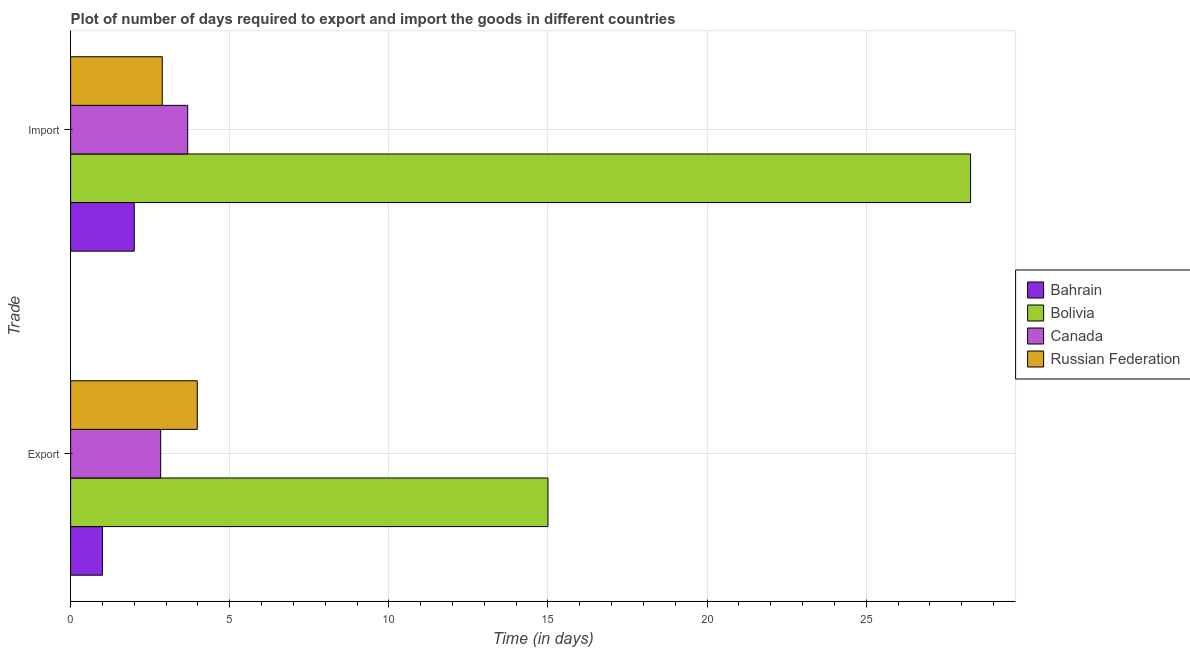How many groups of bars are there?
Provide a succinct answer. 2. Are the number of bars on each tick of the Y-axis equal?
Your response must be concise. Yes. What is the label of the 1st group of bars from the top?
Give a very brief answer. Import. Across all countries, what is the minimum time required to import?
Your response must be concise. 2. In which country was the time required to export maximum?
Keep it short and to the point. Bolivia. In which country was the time required to export minimum?
Your answer should be very brief. Bahrain. What is the total time required to import in the graph?
Give a very brief answer. 36.84. What is the difference between the time required to export in Bahrain and that in Canada?
Provide a succinct answer. -1.83. What is the difference between the time required to export in Bolivia and the time required to import in Russian Federation?
Give a very brief answer. 12.12. What is the average time required to import per country?
Your answer should be compact. 9.21. In how many countries, is the time required to import greater than 18 days?
Provide a succinct answer. 1. What is the ratio of the time required to import in Russian Federation to that in Bahrain?
Your response must be concise. 1.44. Is the time required to import in Bahrain less than that in Canada?
Ensure brevity in your answer.  Yes. In how many countries, is the time required to export greater than the average time required to export taken over all countries?
Make the answer very short. 1. What does the 2nd bar from the top in Import represents?
Provide a succinct answer. Canada. How many countries are there in the graph?
Offer a very short reply. 4. Does the graph contain grids?
Give a very brief answer. Yes. Where does the legend appear in the graph?
Provide a short and direct response. Center right. What is the title of the graph?
Your answer should be compact. Plot of number of days required to export and import the goods in different countries. Does "Lower middle income" appear as one of the legend labels in the graph?
Your answer should be very brief. No. What is the label or title of the X-axis?
Offer a very short reply. Time (in days). What is the label or title of the Y-axis?
Keep it short and to the point. Trade. What is the Time (in days) in Bahrain in Export?
Your answer should be very brief. 1. What is the Time (in days) of Bolivia in Export?
Provide a succinct answer. 15. What is the Time (in days) of Canada in Export?
Offer a very short reply. 2.83. What is the Time (in days) of Russian Federation in Export?
Your answer should be compact. 3.98. What is the Time (in days) of Bahrain in Import?
Provide a succinct answer. 2. What is the Time (in days) in Bolivia in Import?
Provide a succinct answer. 28.28. What is the Time (in days) of Canada in Import?
Your answer should be very brief. 3.68. What is the Time (in days) of Russian Federation in Import?
Make the answer very short. 2.88. Across all Trade, what is the maximum Time (in days) in Bahrain?
Offer a very short reply. 2. Across all Trade, what is the maximum Time (in days) of Bolivia?
Give a very brief answer. 28.28. Across all Trade, what is the maximum Time (in days) of Canada?
Make the answer very short. 3.68. Across all Trade, what is the maximum Time (in days) of Russian Federation?
Keep it short and to the point. 3.98. Across all Trade, what is the minimum Time (in days) of Bahrain?
Make the answer very short. 1. Across all Trade, what is the minimum Time (in days) in Canada?
Keep it short and to the point. 2.83. Across all Trade, what is the minimum Time (in days) in Russian Federation?
Your response must be concise. 2.88. What is the total Time (in days) in Bahrain in the graph?
Make the answer very short. 3. What is the total Time (in days) of Bolivia in the graph?
Offer a very short reply. 43.28. What is the total Time (in days) of Canada in the graph?
Keep it short and to the point. 6.51. What is the total Time (in days) of Russian Federation in the graph?
Your answer should be compact. 6.86. What is the difference between the Time (in days) in Bolivia in Export and that in Import?
Your response must be concise. -13.28. What is the difference between the Time (in days) of Canada in Export and that in Import?
Give a very brief answer. -0.85. What is the difference between the Time (in days) of Russian Federation in Export and that in Import?
Provide a succinct answer. 1.1. What is the difference between the Time (in days) in Bahrain in Export and the Time (in days) in Bolivia in Import?
Your response must be concise. -27.28. What is the difference between the Time (in days) of Bahrain in Export and the Time (in days) of Canada in Import?
Offer a very short reply. -2.68. What is the difference between the Time (in days) of Bahrain in Export and the Time (in days) of Russian Federation in Import?
Provide a short and direct response. -1.88. What is the difference between the Time (in days) in Bolivia in Export and the Time (in days) in Canada in Import?
Your answer should be very brief. 11.32. What is the difference between the Time (in days) in Bolivia in Export and the Time (in days) in Russian Federation in Import?
Provide a short and direct response. 12.12. What is the average Time (in days) of Bahrain per Trade?
Offer a terse response. 1.5. What is the average Time (in days) in Bolivia per Trade?
Give a very brief answer. 21.64. What is the average Time (in days) of Canada per Trade?
Ensure brevity in your answer.  3.25. What is the average Time (in days) of Russian Federation per Trade?
Offer a very short reply. 3.43. What is the difference between the Time (in days) in Bahrain and Time (in days) in Bolivia in Export?
Keep it short and to the point. -14. What is the difference between the Time (in days) of Bahrain and Time (in days) of Canada in Export?
Provide a short and direct response. -1.83. What is the difference between the Time (in days) in Bahrain and Time (in days) in Russian Federation in Export?
Provide a short and direct response. -2.98. What is the difference between the Time (in days) of Bolivia and Time (in days) of Canada in Export?
Give a very brief answer. 12.17. What is the difference between the Time (in days) in Bolivia and Time (in days) in Russian Federation in Export?
Your answer should be compact. 11.02. What is the difference between the Time (in days) of Canada and Time (in days) of Russian Federation in Export?
Keep it short and to the point. -1.15. What is the difference between the Time (in days) in Bahrain and Time (in days) in Bolivia in Import?
Provide a short and direct response. -26.28. What is the difference between the Time (in days) of Bahrain and Time (in days) of Canada in Import?
Your response must be concise. -1.68. What is the difference between the Time (in days) in Bahrain and Time (in days) in Russian Federation in Import?
Provide a succinct answer. -0.88. What is the difference between the Time (in days) of Bolivia and Time (in days) of Canada in Import?
Provide a short and direct response. 24.6. What is the difference between the Time (in days) in Bolivia and Time (in days) in Russian Federation in Import?
Make the answer very short. 25.4. What is the ratio of the Time (in days) in Bolivia in Export to that in Import?
Ensure brevity in your answer.  0.53. What is the ratio of the Time (in days) of Canada in Export to that in Import?
Make the answer very short. 0.77. What is the ratio of the Time (in days) of Russian Federation in Export to that in Import?
Keep it short and to the point. 1.38. What is the difference between the highest and the second highest Time (in days) in Bahrain?
Offer a terse response. 1. What is the difference between the highest and the second highest Time (in days) of Bolivia?
Offer a very short reply. 13.28. What is the difference between the highest and the lowest Time (in days) of Bolivia?
Offer a terse response. 13.28. What is the difference between the highest and the lowest Time (in days) of Canada?
Ensure brevity in your answer.  0.85. What is the difference between the highest and the lowest Time (in days) in Russian Federation?
Your response must be concise. 1.1. 